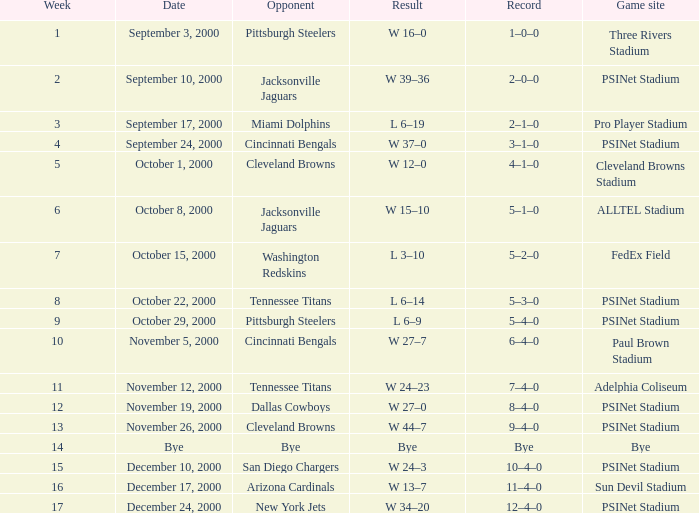What game site has a result of bye? Bye. 